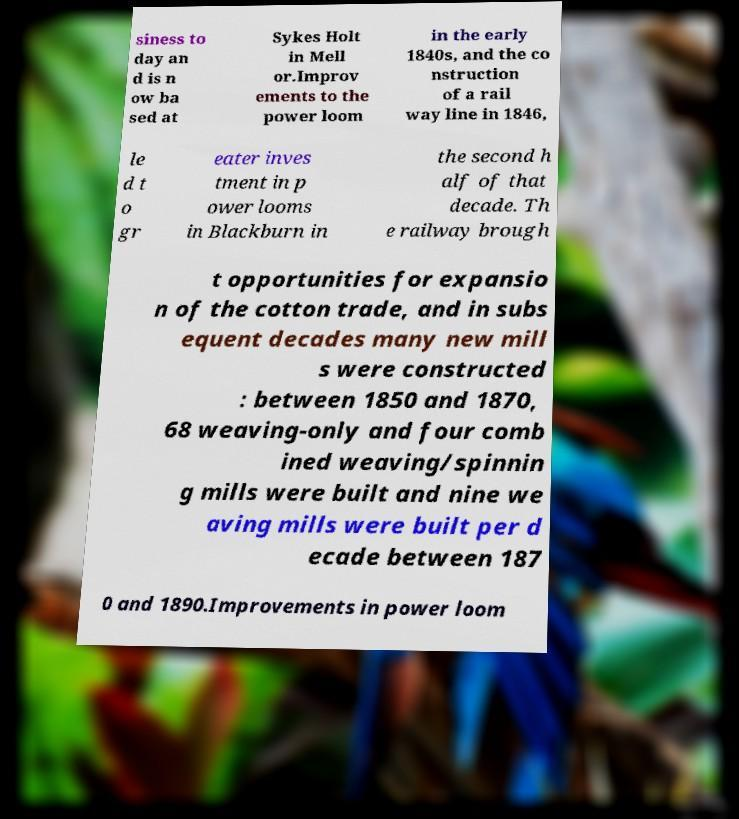Can you accurately transcribe the text from the provided image for me? siness to day an d is n ow ba sed at Sykes Holt in Mell or.Improv ements to the power loom in the early 1840s, and the co nstruction of a rail way line in 1846, le d t o gr eater inves tment in p ower looms in Blackburn in the second h alf of that decade. Th e railway brough t opportunities for expansio n of the cotton trade, and in subs equent decades many new mill s were constructed : between 1850 and 1870, 68 weaving-only and four comb ined weaving/spinnin g mills were built and nine we aving mills were built per d ecade between 187 0 and 1890.Improvements in power loom 